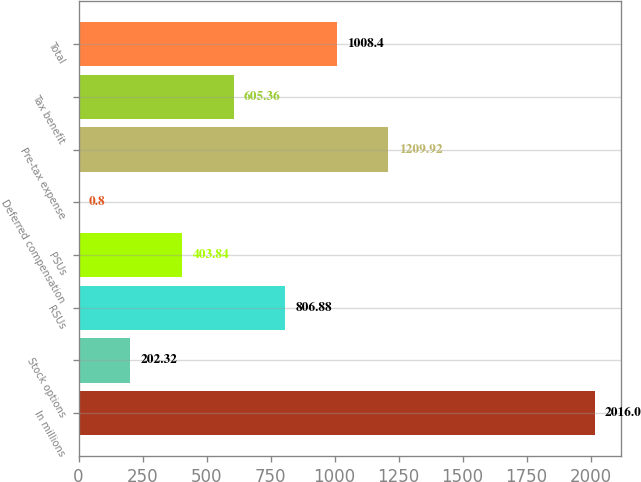Convert chart. <chart><loc_0><loc_0><loc_500><loc_500><bar_chart><fcel>In millions<fcel>Stock options<fcel>RSUs<fcel>PSUs<fcel>Deferred compensation<fcel>Pre-tax expense<fcel>Tax benefit<fcel>Total<nl><fcel>2016<fcel>202.32<fcel>806.88<fcel>403.84<fcel>0.8<fcel>1209.92<fcel>605.36<fcel>1008.4<nl></chart> 